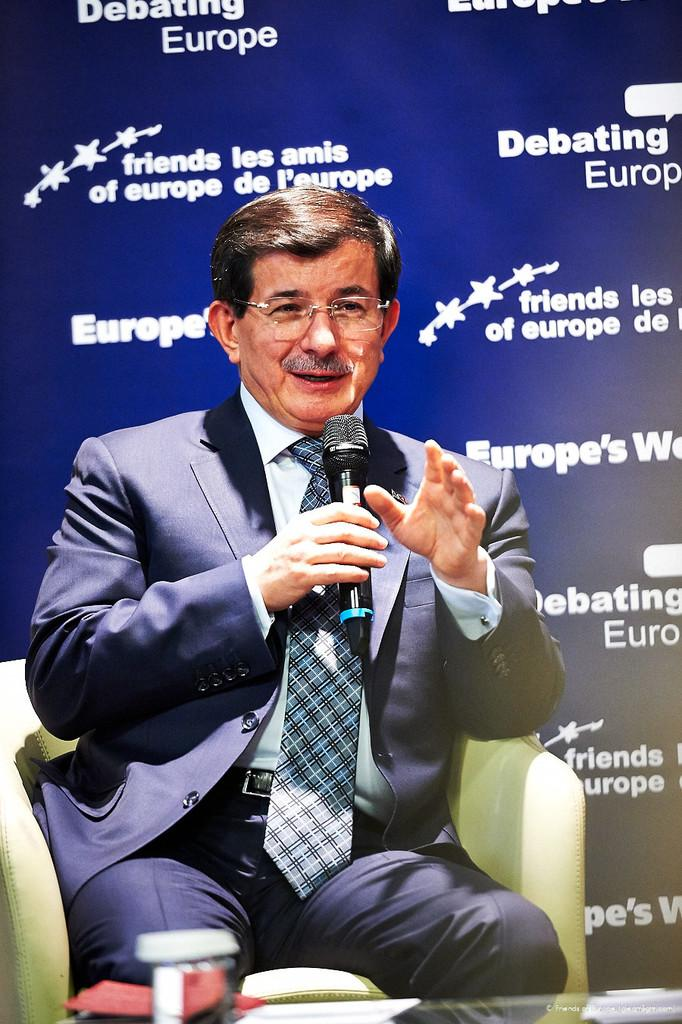What is the man in the image wearing? The man is wearing a blazer and a tie. What accessory is the man wearing on his face? The man is wearing spectacles. What is the man holding in his hand? The man is holding a microphone in his hand. What is the man doing in the image? The man is talking. What is present in front of the man? There is a table in front of the man. What is on the table? There is a glass on the table. What can be seen in the background of the image? There is a banner in the background of the image. Can you see a squirrel smashing a glass in the image? No, there is no squirrel or glass-smashing activity present in the image. 